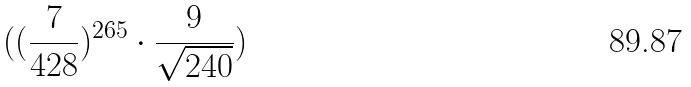<formula> <loc_0><loc_0><loc_500><loc_500>( ( \frac { 7 } { 4 2 8 } ) ^ { 2 6 5 } \cdot \frac { 9 } { \sqrt { 2 4 0 } } )</formula> 